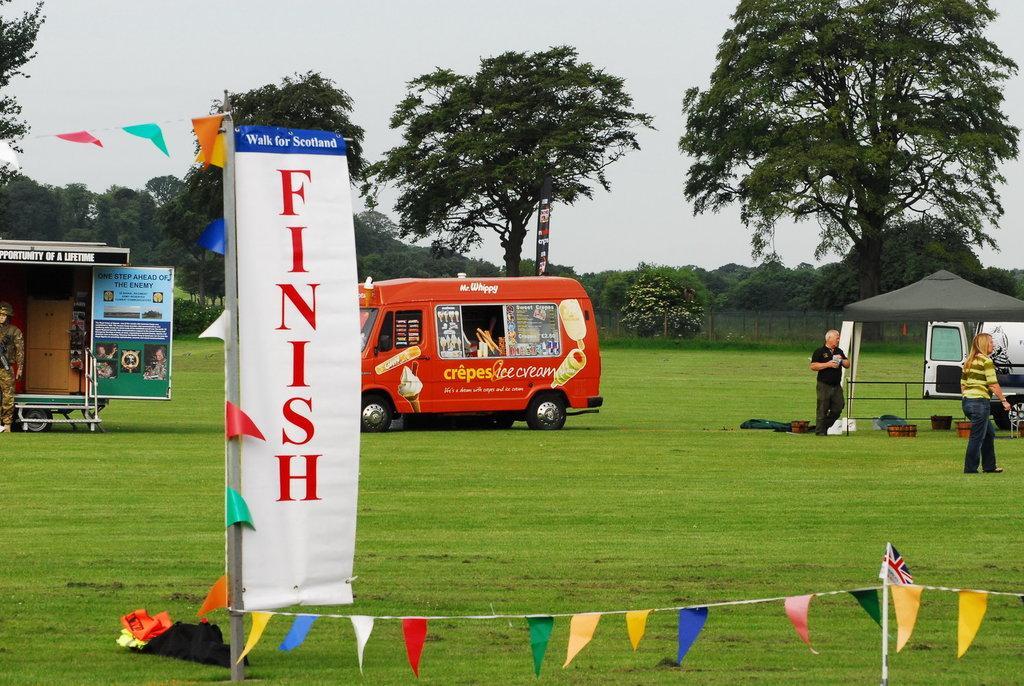In one or two sentences, can you explain what this image depicts? Land is covered with grass. Here we can see flags and banners. Background there is a tent, vehicles, people and trees. On this grass there are buckets and objects. 